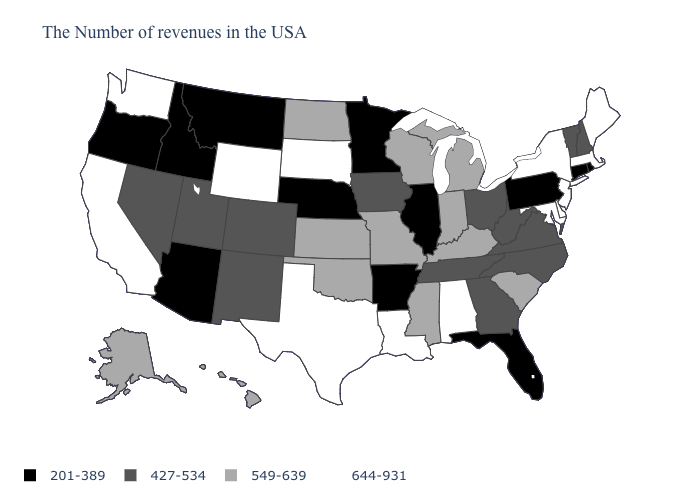What is the value of Rhode Island?
Give a very brief answer. 201-389. Among the states that border Utah , which have the highest value?
Write a very short answer. Wyoming. Name the states that have a value in the range 644-931?
Answer briefly. Maine, Massachusetts, New York, New Jersey, Delaware, Maryland, Alabama, Louisiana, Texas, South Dakota, Wyoming, California, Washington. What is the value of North Dakota?
Write a very short answer. 549-639. How many symbols are there in the legend?
Give a very brief answer. 4. What is the highest value in states that border Colorado?
Answer briefly. 644-931. What is the value of Maine?
Quick response, please. 644-931. What is the lowest value in the USA?
Write a very short answer. 201-389. Which states have the highest value in the USA?
Keep it brief. Maine, Massachusetts, New York, New Jersey, Delaware, Maryland, Alabama, Louisiana, Texas, South Dakota, Wyoming, California, Washington. What is the lowest value in the USA?
Concise answer only. 201-389. Does Massachusetts have the highest value in the USA?
Concise answer only. Yes. What is the lowest value in the Northeast?
Be succinct. 201-389. Which states have the lowest value in the USA?
Be succinct. Rhode Island, Connecticut, Pennsylvania, Florida, Illinois, Arkansas, Minnesota, Nebraska, Montana, Arizona, Idaho, Oregon. Among the states that border Nebraska , which have the lowest value?
Give a very brief answer. Iowa, Colorado. What is the lowest value in states that border Colorado?
Concise answer only. 201-389. 